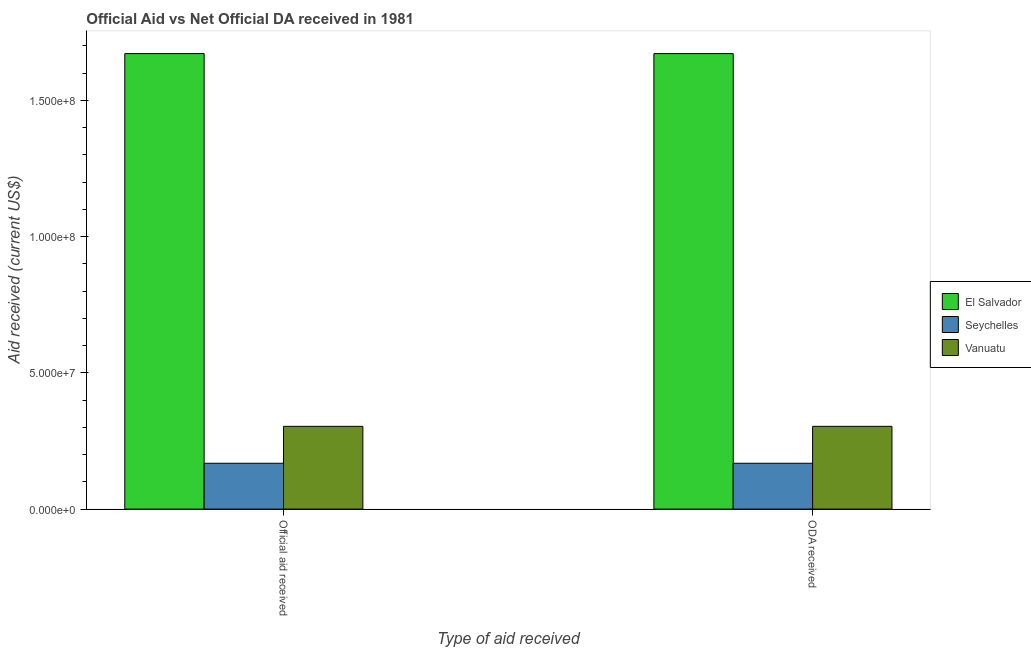How many groups of bars are there?
Offer a terse response. 2. Are the number of bars on each tick of the X-axis equal?
Make the answer very short. Yes. How many bars are there on the 2nd tick from the right?
Make the answer very short. 3. What is the label of the 1st group of bars from the left?
Offer a very short reply. Official aid received. What is the official aid received in Vanuatu?
Ensure brevity in your answer.  3.04e+07. Across all countries, what is the maximum oda received?
Provide a short and direct response. 1.67e+08. Across all countries, what is the minimum oda received?
Give a very brief answer. 1.68e+07. In which country was the official aid received maximum?
Offer a very short reply. El Salvador. In which country was the oda received minimum?
Your response must be concise. Seychelles. What is the total oda received in the graph?
Your response must be concise. 2.14e+08. What is the difference between the official aid received in Seychelles and that in El Salvador?
Offer a very short reply. -1.50e+08. What is the difference between the oda received in Seychelles and the official aid received in El Salvador?
Your response must be concise. -1.50e+08. What is the average official aid received per country?
Your response must be concise. 7.15e+07. What is the difference between the official aid received and oda received in Seychelles?
Give a very brief answer. 0. What is the ratio of the official aid received in Vanuatu to that in Seychelles?
Provide a succinct answer. 1.81. Is the official aid received in El Salvador less than that in Vanuatu?
Keep it short and to the point. No. What does the 2nd bar from the left in Official aid received represents?
Give a very brief answer. Seychelles. What does the 1st bar from the right in Official aid received represents?
Provide a short and direct response. Vanuatu. How many bars are there?
Offer a terse response. 6. Are all the bars in the graph horizontal?
Keep it short and to the point. No. Are the values on the major ticks of Y-axis written in scientific E-notation?
Your answer should be very brief. Yes. Does the graph contain any zero values?
Ensure brevity in your answer.  No. How are the legend labels stacked?
Your answer should be very brief. Vertical. What is the title of the graph?
Offer a terse response. Official Aid vs Net Official DA received in 1981 . What is the label or title of the X-axis?
Make the answer very short. Type of aid received. What is the label or title of the Y-axis?
Offer a terse response. Aid received (current US$). What is the Aid received (current US$) of El Salvador in Official aid received?
Offer a terse response. 1.67e+08. What is the Aid received (current US$) in Seychelles in Official aid received?
Ensure brevity in your answer.  1.68e+07. What is the Aid received (current US$) in Vanuatu in Official aid received?
Your answer should be very brief. 3.04e+07. What is the Aid received (current US$) of El Salvador in ODA received?
Make the answer very short. 1.67e+08. What is the Aid received (current US$) in Seychelles in ODA received?
Give a very brief answer. 1.68e+07. What is the Aid received (current US$) in Vanuatu in ODA received?
Your answer should be very brief. 3.04e+07. Across all Type of aid received, what is the maximum Aid received (current US$) of El Salvador?
Make the answer very short. 1.67e+08. Across all Type of aid received, what is the maximum Aid received (current US$) in Seychelles?
Provide a succinct answer. 1.68e+07. Across all Type of aid received, what is the maximum Aid received (current US$) in Vanuatu?
Provide a short and direct response. 3.04e+07. Across all Type of aid received, what is the minimum Aid received (current US$) of El Salvador?
Your answer should be compact. 1.67e+08. Across all Type of aid received, what is the minimum Aid received (current US$) in Seychelles?
Provide a short and direct response. 1.68e+07. Across all Type of aid received, what is the minimum Aid received (current US$) in Vanuatu?
Your answer should be very brief. 3.04e+07. What is the total Aid received (current US$) of El Salvador in the graph?
Ensure brevity in your answer.  3.34e+08. What is the total Aid received (current US$) of Seychelles in the graph?
Your answer should be very brief. 3.37e+07. What is the total Aid received (current US$) in Vanuatu in the graph?
Keep it short and to the point. 6.08e+07. What is the difference between the Aid received (current US$) in El Salvador in Official aid received and the Aid received (current US$) in Seychelles in ODA received?
Your response must be concise. 1.50e+08. What is the difference between the Aid received (current US$) of El Salvador in Official aid received and the Aid received (current US$) of Vanuatu in ODA received?
Make the answer very short. 1.37e+08. What is the difference between the Aid received (current US$) in Seychelles in Official aid received and the Aid received (current US$) in Vanuatu in ODA received?
Offer a very short reply. -1.36e+07. What is the average Aid received (current US$) in El Salvador per Type of aid received?
Your response must be concise. 1.67e+08. What is the average Aid received (current US$) in Seychelles per Type of aid received?
Provide a short and direct response. 1.68e+07. What is the average Aid received (current US$) in Vanuatu per Type of aid received?
Make the answer very short. 3.04e+07. What is the difference between the Aid received (current US$) in El Salvador and Aid received (current US$) in Seychelles in Official aid received?
Offer a terse response. 1.50e+08. What is the difference between the Aid received (current US$) in El Salvador and Aid received (current US$) in Vanuatu in Official aid received?
Offer a very short reply. 1.37e+08. What is the difference between the Aid received (current US$) of Seychelles and Aid received (current US$) of Vanuatu in Official aid received?
Your answer should be very brief. -1.36e+07. What is the difference between the Aid received (current US$) in El Salvador and Aid received (current US$) in Seychelles in ODA received?
Ensure brevity in your answer.  1.50e+08. What is the difference between the Aid received (current US$) of El Salvador and Aid received (current US$) of Vanuatu in ODA received?
Offer a terse response. 1.37e+08. What is the difference between the Aid received (current US$) in Seychelles and Aid received (current US$) in Vanuatu in ODA received?
Offer a terse response. -1.36e+07. What is the ratio of the Aid received (current US$) of Seychelles in Official aid received to that in ODA received?
Offer a terse response. 1. What is the difference between the highest and the second highest Aid received (current US$) of El Salvador?
Offer a very short reply. 0. What is the difference between the highest and the second highest Aid received (current US$) of Seychelles?
Your answer should be very brief. 0. What is the difference between the highest and the second highest Aid received (current US$) of Vanuatu?
Your response must be concise. 0. What is the difference between the highest and the lowest Aid received (current US$) of El Salvador?
Ensure brevity in your answer.  0. What is the difference between the highest and the lowest Aid received (current US$) in Seychelles?
Provide a short and direct response. 0. What is the difference between the highest and the lowest Aid received (current US$) in Vanuatu?
Your response must be concise. 0. 